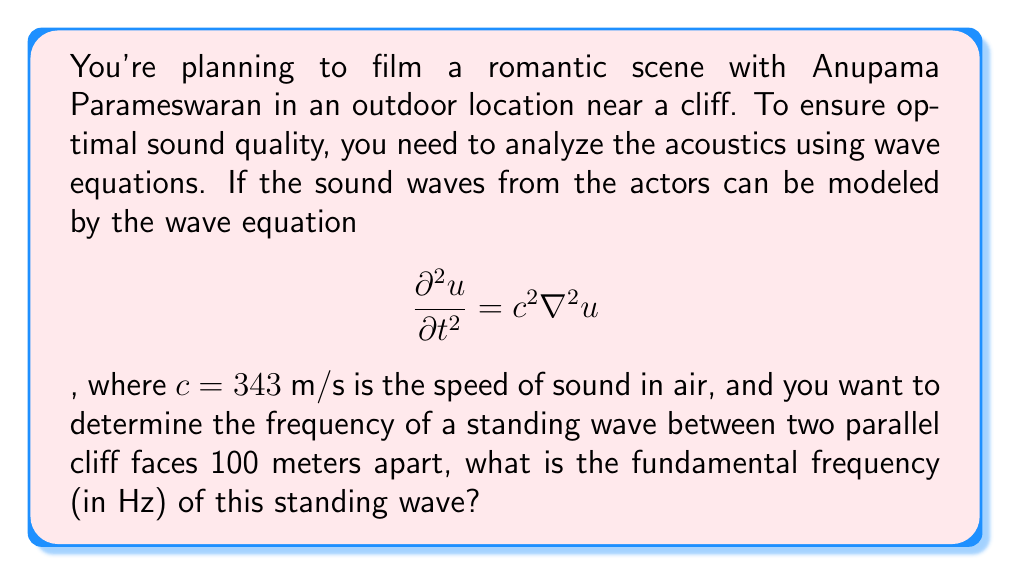Teach me how to tackle this problem. Let's approach this step-by-step:

1) For a standing wave between two parallel surfaces, the wavelength $\lambda$ is related to the distance $L$ between the surfaces by:

   $$L = \frac{n\lambda}{2}$$

   where $n$ is a positive integer. The fundamental frequency corresponds to $n=1$.

2) In this case, $L = 100$ m, so for the fundamental frequency:

   $$100 = \frac{\lambda}{2}$$
   $$\lambda = 200 \text{ m}$$

3) The wave equation given is:

   $$\frac{\partial^2 u}{\partial t^2} = c^2 \nabla^2 u$$

   where $c = 343$ m/s is the speed of sound in air.

4) For any wave, the relationship between speed $c$, frequency $f$, and wavelength $\lambda$ is:

   $$c = f\lambda$$

5) Rearranging this equation and substituting our known values:

   $$f = \frac{c}{\lambda} = \frac{343}{200} = 1.715 \text{ Hz}$$

Therefore, the fundamental frequency of the standing wave is approximately 1.715 Hz.
Answer: 1.715 Hz 